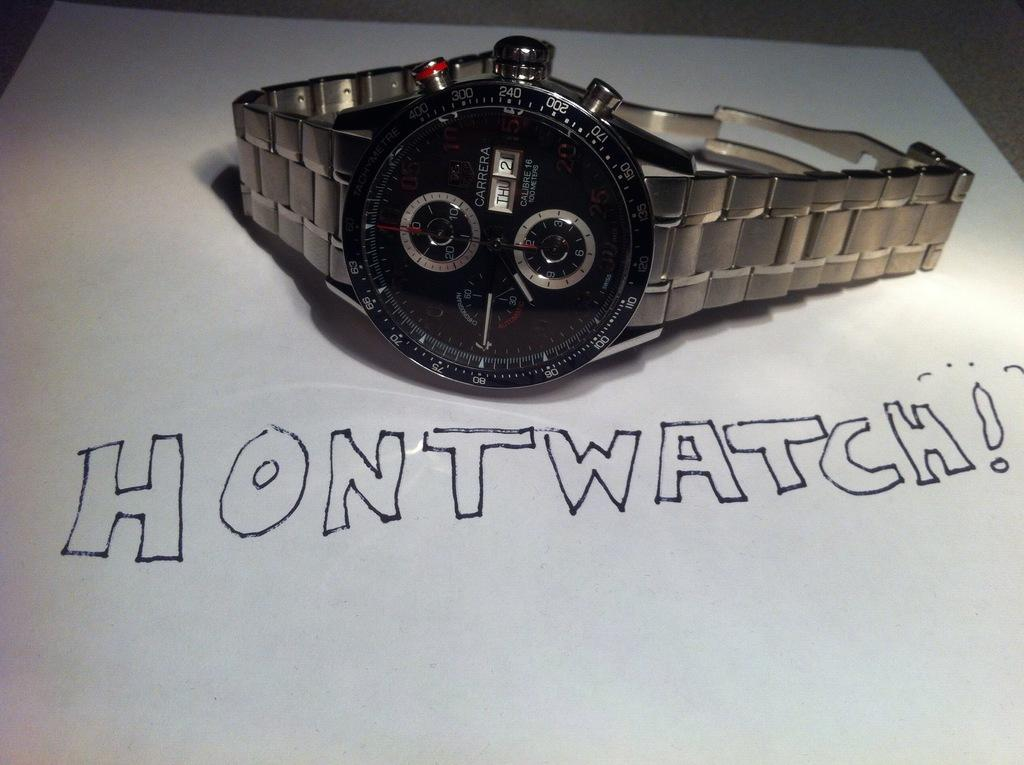<image>
Share a concise interpretation of the image provided. A silver and black Carrera wristwatch laying on a table with the word Hontwatch written below it. 